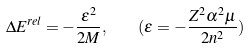Convert formula to latex. <formula><loc_0><loc_0><loc_500><loc_500>\Delta E ^ { r e l } = - \frac { \varepsilon ^ { 2 } } { 2 M } , \quad ( \varepsilon = - \frac { Z ^ { 2 } \alpha ^ { 2 } \mu } { 2 n ^ { 2 } } )</formula> 